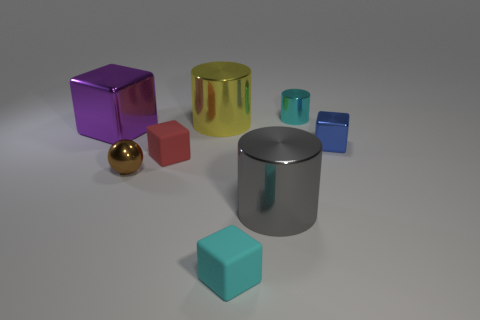Subtract all large cylinders. How many cylinders are left? 1 Subtract all gray blocks. Subtract all yellow cylinders. How many blocks are left? 4 Add 2 tiny purple matte balls. How many objects exist? 10 Subtract all balls. How many objects are left? 7 Subtract 0 gray spheres. How many objects are left? 8 Subtract all cyan metal spheres. Subtract all small rubber things. How many objects are left? 6 Add 3 big metallic cylinders. How many big metallic cylinders are left? 5 Add 7 tiny blue objects. How many tiny blue objects exist? 8 